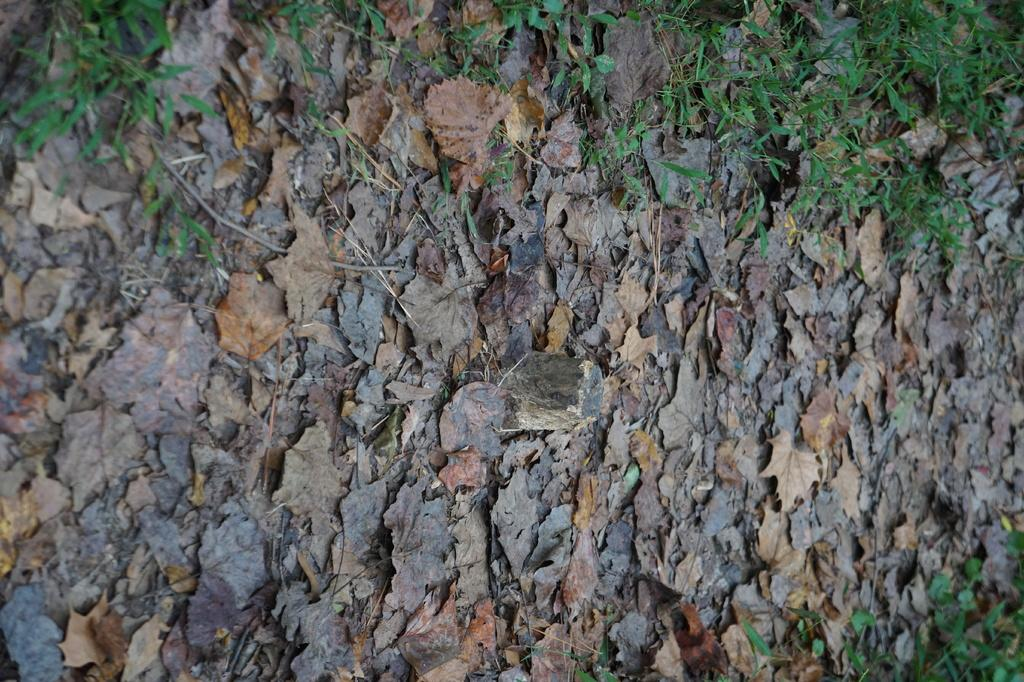What type of living organisms can be seen in the image? Plants can be seen in the image. What is the color of the plants in the image? The plants are green. What else can be observed about the plants in the image? There are dried leaves in the image. What type of minister is depicted in the image? There is no minister present in the image; it features plants with green leaves and dried leaves. What type of comb is used to groom the plants in the image? There is no comb present in the image, as plants do not require grooming with a comb. 